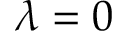<formula> <loc_0><loc_0><loc_500><loc_500>\lambda = 0</formula> 